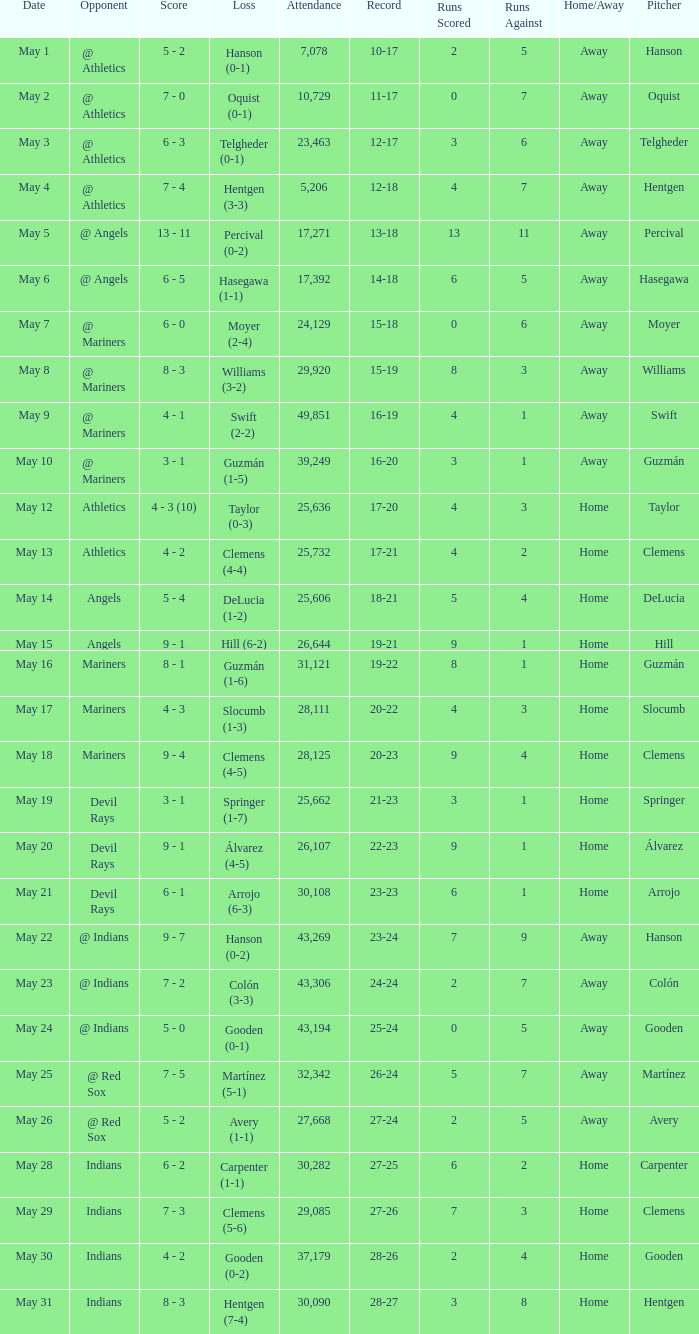What is the record for May 31? 28-27. 